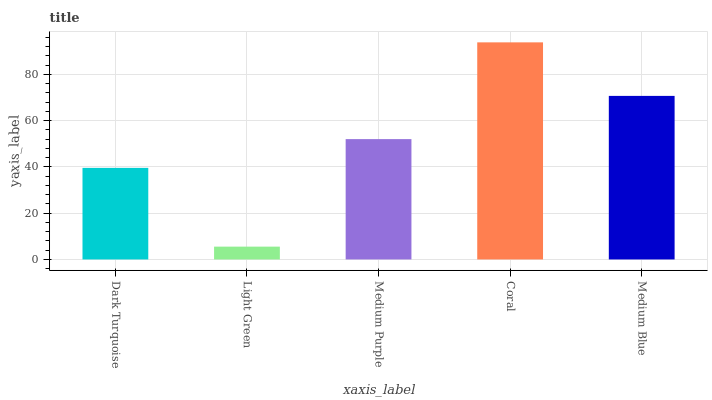Is Medium Purple the minimum?
Answer yes or no. No. Is Medium Purple the maximum?
Answer yes or no. No. Is Medium Purple greater than Light Green?
Answer yes or no. Yes. Is Light Green less than Medium Purple?
Answer yes or no. Yes. Is Light Green greater than Medium Purple?
Answer yes or no. No. Is Medium Purple less than Light Green?
Answer yes or no. No. Is Medium Purple the high median?
Answer yes or no. Yes. Is Medium Purple the low median?
Answer yes or no. Yes. Is Light Green the high median?
Answer yes or no. No. Is Dark Turquoise the low median?
Answer yes or no. No. 